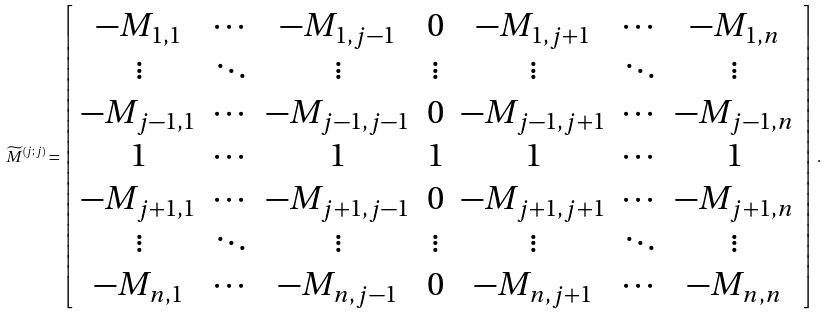Convert formula to latex. <formula><loc_0><loc_0><loc_500><loc_500>\widetilde { M } ^ { ( j ; j ) } = \left [ \begin{array} { * { 7 } { c } } - M _ { 1 , 1 } & \cdots & - M _ { 1 , j - 1 } & 0 & - M _ { 1 , j + 1 } & \cdots & - M _ { 1 , n } \\ \vdots & \ddots & \vdots & \vdots & \vdots & \ddots & \vdots \\ - M _ { j - 1 , 1 } & \cdots & - M _ { j - 1 , j - 1 } & 0 & - M _ { j - 1 , j + 1 } & \cdots & - M _ { j - 1 , n } \\ 1 & \cdots & 1 & 1 & 1 & \cdots & 1 \\ - M _ { j + 1 , 1 } & \cdots & - M _ { j + 1 , j - 1 } & 0 & - M _ { j + 1 , j + 1 } & \cdots & - M _ { j + 1 , n } \\ \vdots & \ddots & \vdots & \vdots & \vdots & \ddots & \vdots \\ - M _ { n , 1 } & \cdots & - M _ { n , j - 1 } & 0 & - M _ { n , j + 1 } & \cdots & - M _ { n , n } \end{array} \right ] \, .</formula> 